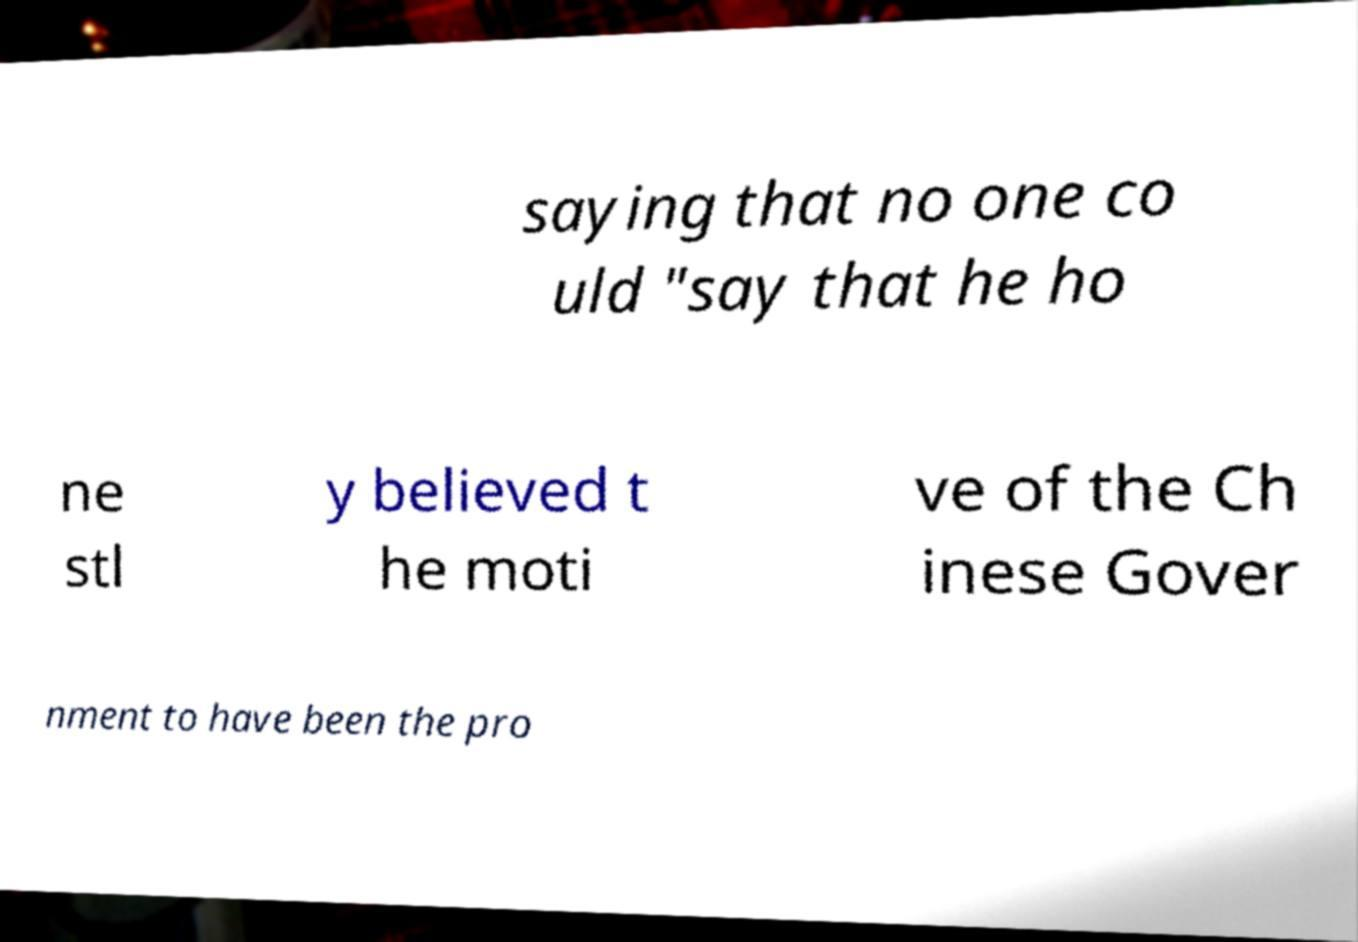Could you assist in decoding the text presented in this image and type it out clearly? saying that no one co uld "say that he ho ne stl y believed t he moti ve of the Ch inese Gover nment to have been the pro 